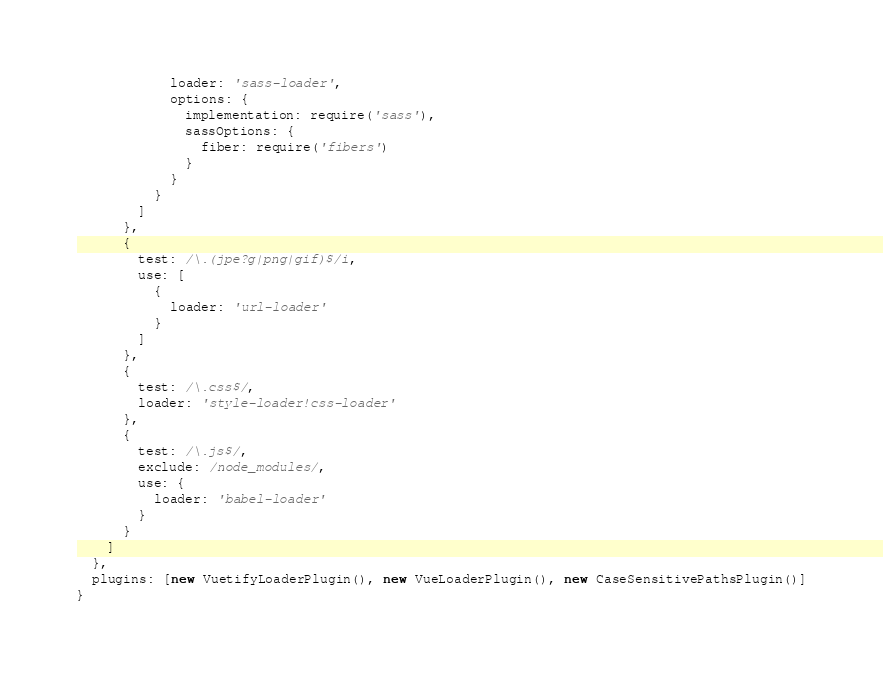<code> <loc_0><loc_0><loc_500><loc_500><_JavaScript_>            loader: 'sass-loader',
            options: {
              implementation: require('sass'),
              sassOptions: {
                fiber: require('fibers')
              }
            }
          }
        ]
      },
      {
        test: /\.(jpe?g|png|gif)$/i,
        use: [
          {
            loader: 'url-loader'
          }
        ]
      },
      {
        test: /\.css$/,
        loader: 'style-loader!css-loader'
      },
      {
        test: /\.js$/,
        exclude: /node_modules/,
        use: {
          loader: 'babel-loader'
        }
      }
    ]
  },
  plugins: [new VuetifyLoaderPlugin(), new VueLoaderPlugin(), new CaseSensitivePathsPlugin()]
}
</code> 